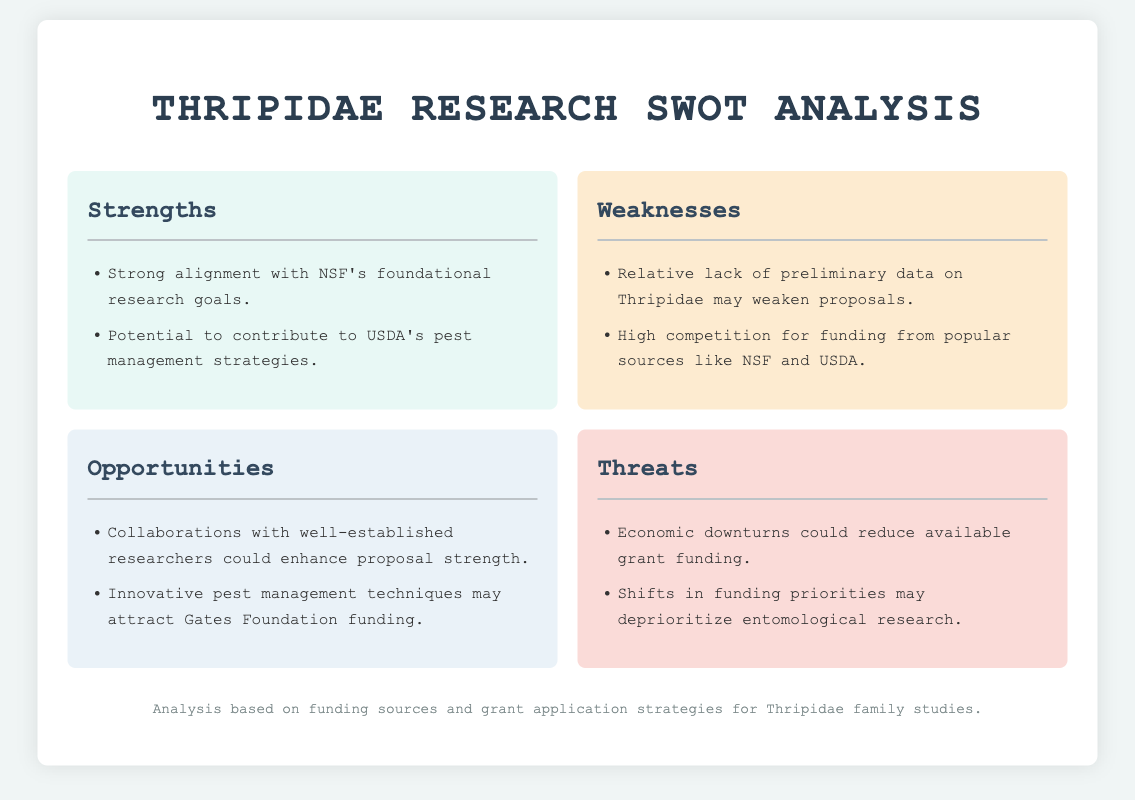What are the two strengths mentioned? The strengths listed in the document are "Strong alignment with NSF's foundational research goals" and "Potential to contribute to USDA's pest management strategies."
Answer: Strong alignment with NSF's foundational research goals; Potential to contribute to USDA's pest management strategies How many weaknesses are identified in the document? The document lists two weaknesses, which are "Relative lack of preliminary data on Thripidae may weaken proposals" and "High competition for funding from popular sources like NSF and USDA."
Answer: 2 What is one opportunity for Thripidae research funding? One opportunity mentioned is "Collaborations with well-established researchers could enhance proposal strength."
Answer: Collaborations with well-established researchers could enhance proposal strength What is a potential threat to Thripidae funding mentioned? A threat mentioned is "Economic downturns could reduce available grant funding."
Answer: Economic downturns could reduce available grant funding Which foundation may fund innovative pest management techniques? The document suggests that "Innovative pest management techniques may attract Gates Foundation funding."
Answer: Gates Foundation What color is used for the weaknesses section in the document? The weaknesses section is described to have a background color of "#fdebd0," which corresponds to a beige tone.
Answer: #fdebd0 What is the primary theme of the analysis in the document? The primary theme centers around funding sources and grant application strategies for studies focusing on the Thripidae family.
Answer: Funding sources and grant application strategies for Thripidae family studies 